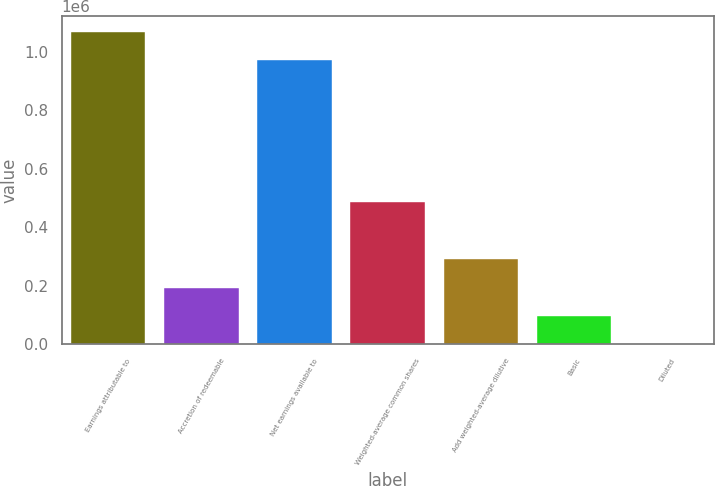Convert chart. <chart><loc_0><loc_0><loc_500><loc_500><bar_chart><fcel>Earnings attributable to<fcel>Accretion of redeemable<fcel>Net earnings available to<fcel>Weighted-average common shares<fcel>Add weighted-average dilutive<fcel>Basic<fcel>Diluted<nl><fcel>1.06875e+06<fcel>194338<fcel>971592<fcel>485825<fcel>291500<fcel>97175.5<fcel>12.98<nl></chart> 